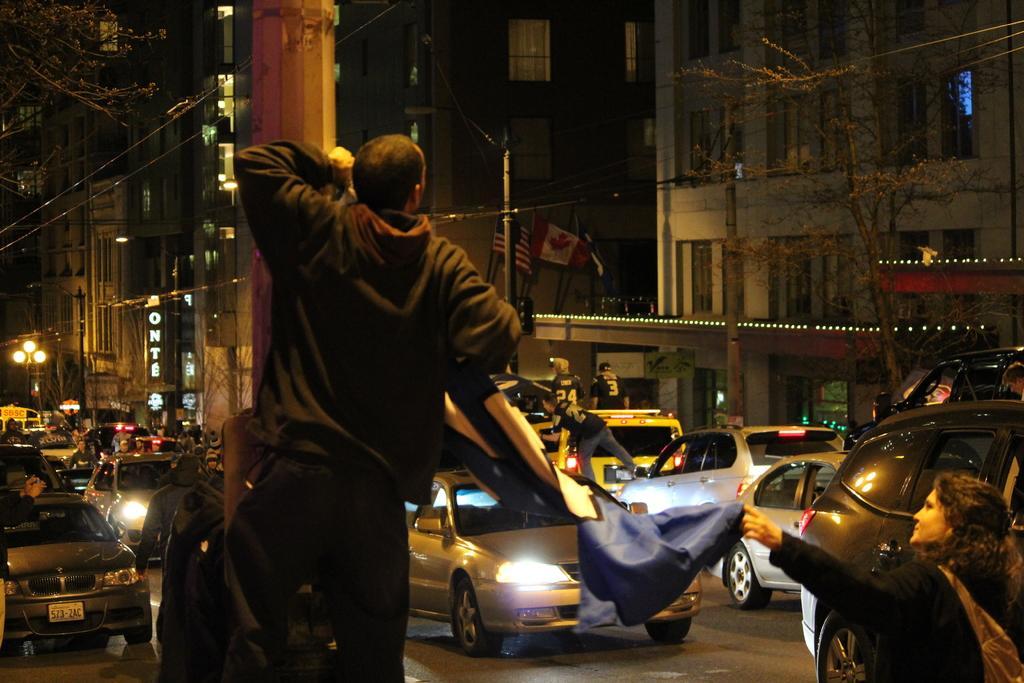In one or two sentences, can you explain what this image depicts? In this image there is a man standing in the middle by holding the pole. In front of him there is a road on which there are so many vehicles. On the right side there are buildings. This image is taken during the night time. The man is holding the flag. There are poles on the footpath. On the left side top there is a tree. 